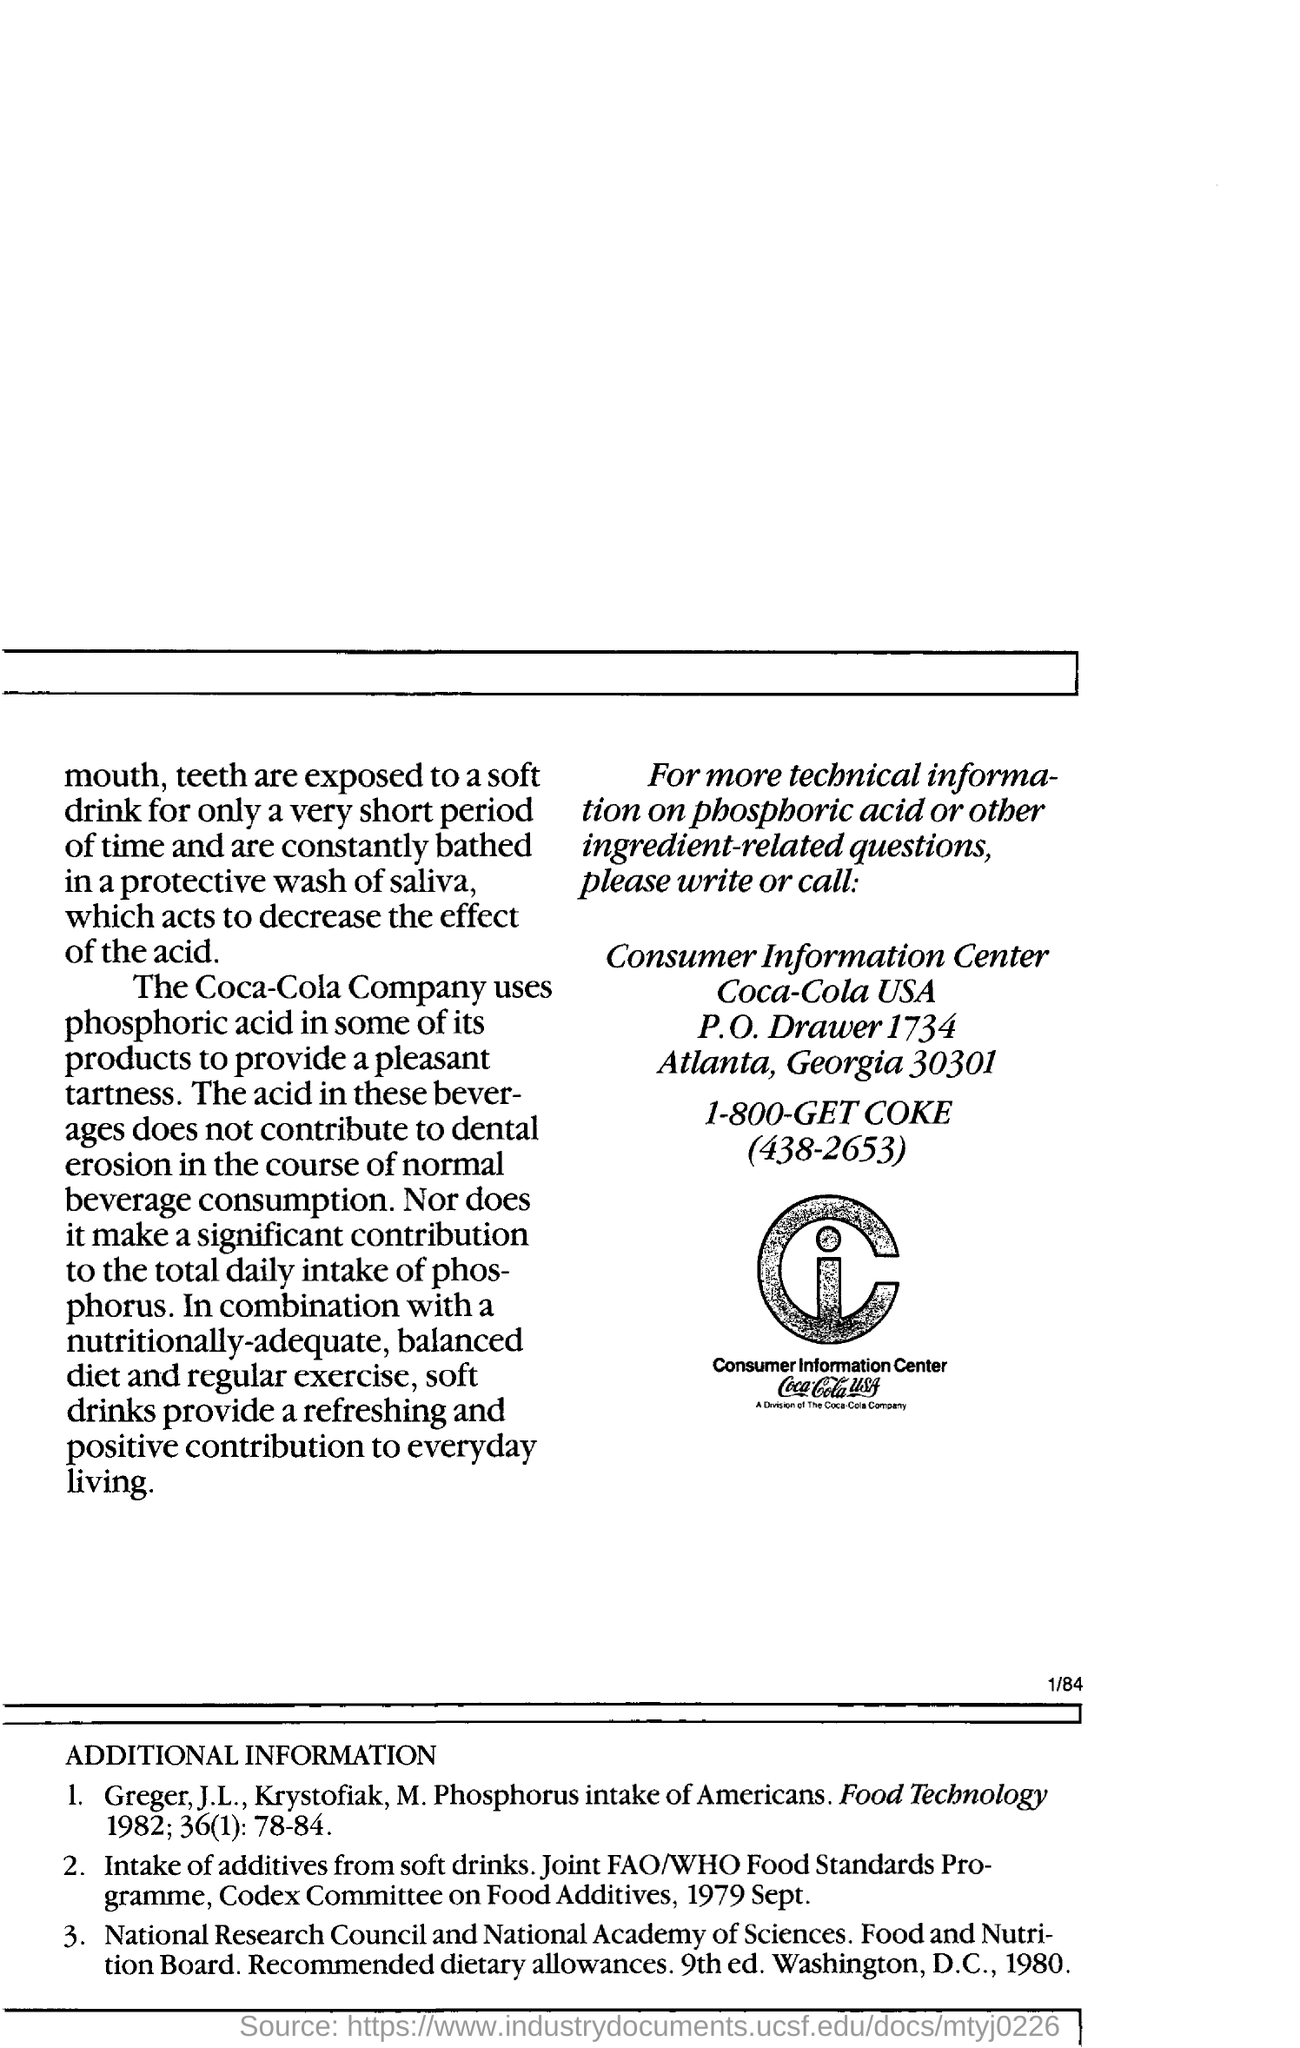Specify some key components in this picture. Soft drinks provide a refreshing and positive contribution to everyday living. The location of the consumer information center is in Atlanta, Georgia, specifically at 30301. The Coca-Cola Company uses phosphoric acid to provide a pleasantly tart flavor in their beverage. 